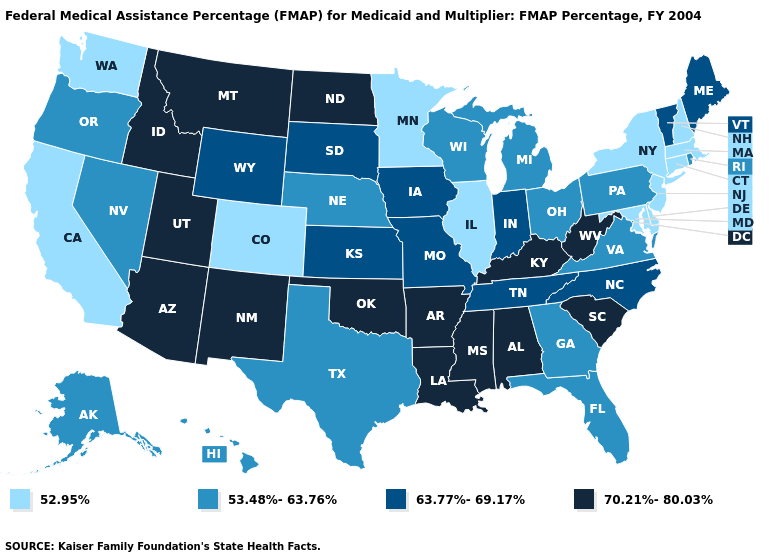What is the highest value in states that border New Jersey?
Keep it brief. 53.48%-63.76%. What is the value of Colorado?
Write a very short answer. 52.95%. Does the first symbol in the legend represent the smallest category?
Be succinct. Yes. Which states hav the highest value in the South?
Be succinct. Alabama, Arkansas, Kentucky, Louisiana, Mississippi, Oklahoma, South Carolina, West Virginia. What is the value of Ohio?
Answer briefly. 53.48%-63.76%. What is the value of Oklahoma?
Be succinct. 70.21%-80.03%. Does Oregon have a lower value than Pennsylvania?
Quick response, please. No. Which states have the lowest value in the Northeast?
Short answer required. Connecticut, Massachusetts, New Hampshire, New Jersey, New York. What is the value of Georgia?
Keep it brief. 53.48%-63.76%. Among the states that border Tennessee , which have the lowest value?
Write a very short answer. Georgia, Virginia. What is the value of New York?
Concise answer only. 52.95%. Which states have the lowest value in the USA?
Be succinct. California, Colorado, Connecticut, Delaware, Illinois, Maryland, Massachusetts, Minnesota, New Hampshire, New Jersey, New York, Washington. What is the value of Nevada?
Answer briefly. 53.48%-63.76%. Name the states that have a value in the range 63.77%-69.17%?
Short answer required. Indiana, Iowa, Kansas, Maine, Missouri, North Carolina, South Dakota, Tennessee, Vermont, Wyoming. Does Oregon have the lowest value in the USA?
Answer briefly. No. 